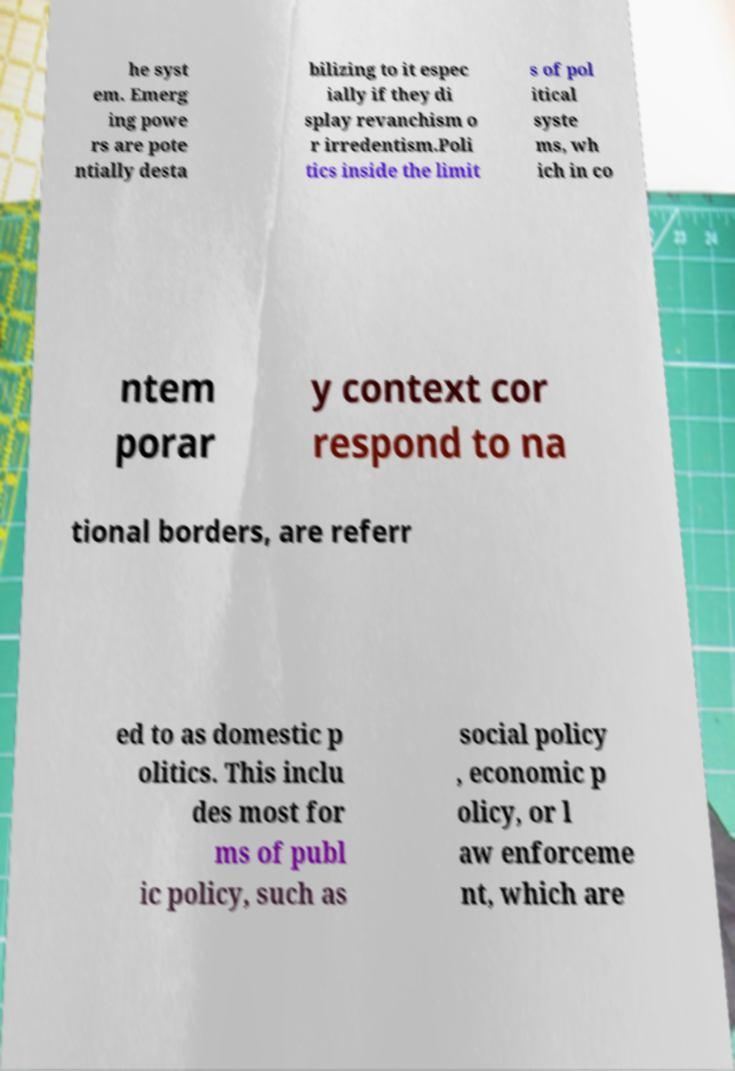Can you accurately transcribe the text from the provided image for me? he syst em. Emerg ing powe rs are pote ntially desta bilizing to it espec ially if they di splay revanchism o r irredentism.Poli tics inside the limit s of pol itical syste ms, wh ich in co ntem porar y context cor respond to na tional borders, are referr ed to as domestic p olitics. This inclu des most for ms of publ ic policy, such as social policy , economic p olicy, or l aw enforceme nt, which are 